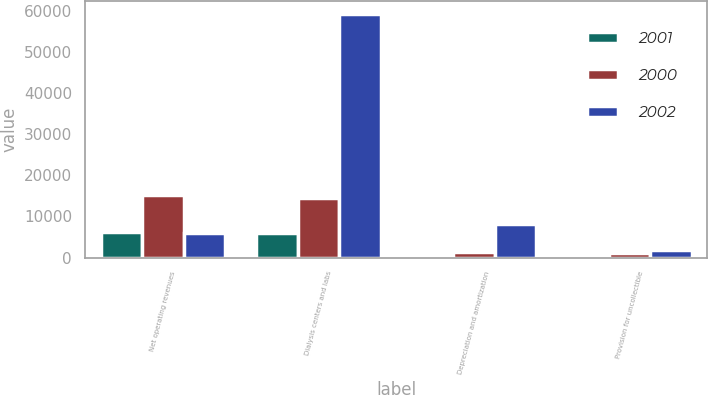<chart> <loc_0><loc_0><loc_500><loc_500><stacked_bar_chart><ecel><fcel>Net operating revenues<fcel>Dialysis centers and labs<fcel>Depreciation and amortization<fcel>Provision for uncollectible<nl><fcel>2001<fcel>6159<fcel>5922<fcel>202<fcel>41<nl><fcel>2000<fcel>15313<fcel>14417<fcel>1311<fcel>1094<nl><fcel>2002<fcel>5922<fcel>59264<fcel>8181<fcel>1728<nl></chart> 